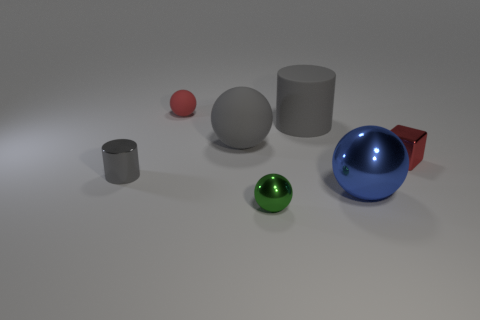Subtract 1 spheres. How many spheres are left? 3 Subtract all brown cylinders. Subtract all cyan balls. How many cylinders are left? 2 Add 3 gray spheres. How many objects exist? 10 Subtract all blocks. How many objects are left? 6 Add 2 small rubber blocks. How many small rubber blocks exist? 2 Subtract 0 gray cubes. How many objects are left? 7 Subtract all small matte spheres. Subtract all red metallic blocks. How many objects are left? 5 Add 5 tiny cylinders. How many tiny cylinders are left? 6 